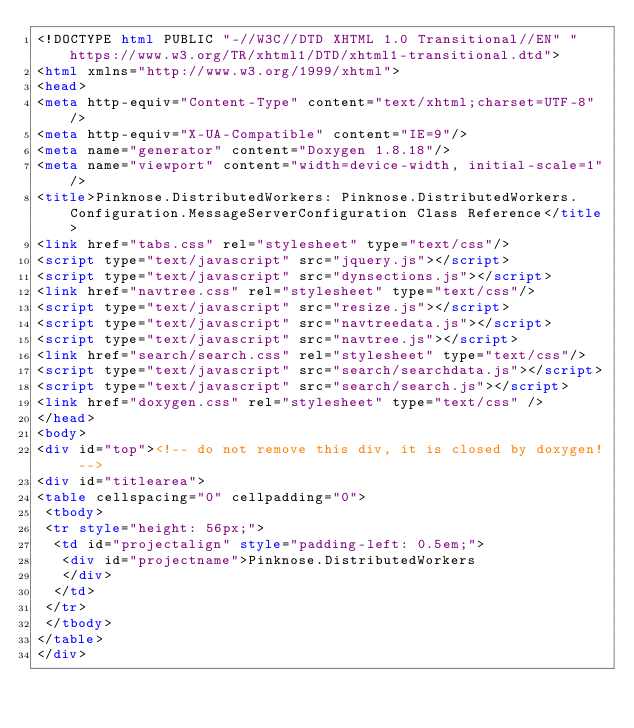<code> <loc_0><loc_0><loc_500><loc_500><_HTML_><!DOCTYPE html PUBLIC "-//W3C//DTD XHTML 1.0 Transitional//EN" "https://www.w3.org/TR/xhtml1/DTD/xhtml1-transitional.dtd">
<html xmlns="http://www.w3.org/1999/xhtml">
<head>
<meta http-equiv="Content-Type" content="text/xhtml;charset=UTF-8"/>
<meta http-equiv="X-UA-Compatible" content="IE=9"/>
<meta name="generator" content="Doxygen 1.8.18"/>
<meta name="viewport" content="width=device-width, initial-scale=1"/>
<title>Pinknose.DistributedWorkers: Pinknose.DistributedWorkers.Configuration.MessageServerConfiguration Class Reference</title>
<link href="tabs.css" rel="stylesheet" type="text/css"/>
<script type="text/javascript" src="jquery.js"></script>
<script type="text/javascript" src="dynsections.js"></script>
<link href="navtree.css" rel="stylesheet" type="text/css"/>
<script type="text/javascript" src="resize.js"></script>
<script type="text/javascript" src="navtreedata.js"></script>
<script type="text/javascript" src="navtree.js"></script>
<link href="search/search.css" rel="stylesheet" type="text/css"/>
<script type="text/javascript" src="search/searchdata.js"></script>
<script type="text/javascript" src="search/search.js"></script>
<link href="doxygen.css" rel="stylesheet" type="text/css" />
</head>
<body>
<div id="top"><!-- do not remove this div, it is closed by doxygen! -->
<div id="titlearea">
<table cellspacing="0" cellpadding="0">
 <tbody>
 <tr style="height: 56px;">
  <td id="projectalign" style="padding-left: 0.5em;">
   <div id="projectname">Pinknose.DistributedWorkers
   </div>
  </td>
 </tr>
 </tbody>
</table>
</div></code> 